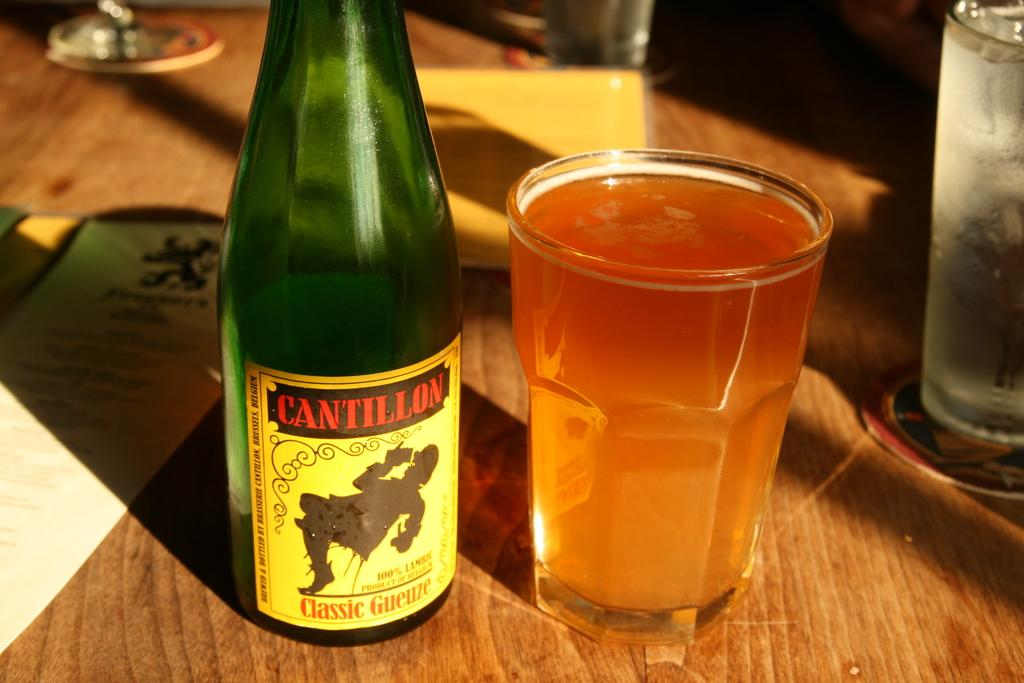<image>
Summarize the visual content of the image. a green bottle bottle has a yellow label with Cantillion in red letters. 